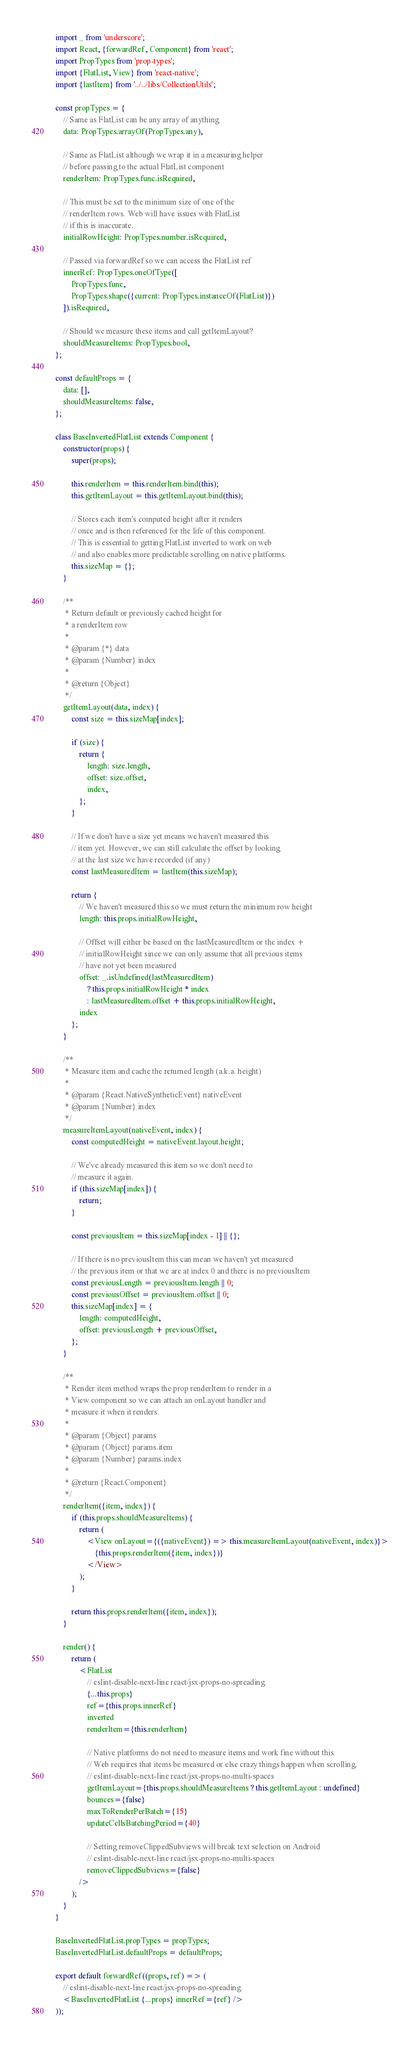Convert code to text. <code><loc_0><loc_0><loc_500><loc_500><_JavaScript_>import _ from 'underscore';
import React, {forwardRef, Component} from 'react';
import PropTypes from 'prop-types';
import {FlatList, View} from 'react-native';
import {lastItem} from '../../libs/CollectionUtils';

const propTypes = {
    // Same as FlatList can be any array of anything
    data: PropTypes.arrayOf(PropTypes.any),

    // Same as FlatList although we wrap it in a measuring helper
    // before passing to the actual FlatList component
    renderItem: PropTypes.func.isRequired,

    // This must be set to the minimum size of one of the
    // renderItem rows. Web will have issues with FlatList
    // if this is inaccurate.
    initialRowHeight: PropTypes.number.isRequired,

    // Passed via forwardRef so we can access the FlatList ref
    innerRef: PropTypes.oneOfType([
        PropTypes.func,
        PropTypes.shape({current: PropTypes.instanceOf(FlatList)})
    ]).isRequired,

    // Should we measure these items and call getItemLayout?
    shouldMeasureItems: PropTypes.bool,
};

const defaultProps = {
    data: [],
    shouldMeasureItems: false,
};

class BaseInvertedFlatList extends Component {
    constructor(props) {
        super(props);

        this.renderItem = this.renderItem.bind(this);
        this.getItemLayout = this.getItemLayout.bind(this);

        // Stores each item's computed height after it renders
        // once and is then referenced for the life of this component.
        // This is essential to getting FlatList inverted to work on web
        // and also enables more predictable scrolling on native platforms.
        this.sizeMap = {};
    }

    /**
     * Return default or previously cached height for
     * a renderItem row
     *
     * @param {*} data
     * @param {Number} index
     *
     * @return {Object}
     */
    getItemLayout(data, index) {
        const size = this.sizeMap[index];

        if (size) {
            return {
                length: size.length,
                offset: size.offset,
                index,
            };
        }

        // If we don't have a size yet means we haven't measured this
        // item yet. However, we can still calculate the offset by looking
        // at the last size we have recorded (if any)
        const lastMeasuredItem = lastItem(this.sizeMap);

        return {
            // We haven't measured this so we must return the minimum row height
            length: this.props.initialRowHeight,

            // Offset will either be based on the lastMeasuredItem or the index +
            // initialRowHeight since we can only assume that all previous items
            // have not yet been measured
            offset: _.isUndefined(lastMeasuredItem)
                ? this.props.initialRowHeight * index
                : lastMeasuredItem.offset + this.props.initialRowHeight,
            index
        };
    }

    /**
     * Measure item and cache the returned length (a.k.a. height)
     *
     * @param {React.NativeSyntheticEvent} nativeEvent
     * @param {Number} index
     */
    measureItemLayout(nativeEvent, index) {
        const computedHeight = nativeEvent.layout.height;

        // We've already measured this item so we don't need to
        // measure it again.
        if (this.sizeMap[index]) {
            return;
        }

        const previousItem = this.sizeMap[index - 1] || {};

        // If there is no previousItem this can mean we haven't yet measured
        // the previous item or that we are at index 0 and there is no previousItem
        const previousLength = previousItem.length || 0;
        const previousOffset = previousItem.offset || 0;
        this.sizeMap[index] = {
            length: computedHeight,
            offset: previousLength + previousOffset,
        };
    }

    /**
     * Render item method wraps the prop renderItem to render in a
     * View component so we can attach an onLayout handler and
     * measure it when it renders.
     *
     * @param {Object} params
     * @param {Object} params.item
     * @param {Number} params.index
     *
     * @return {React.Component}
     */
    renderItem({item, index}) {
        if (this.props.shouldMeasureItems) {
            return (
                <View onLayout={({nativeEvent}) => this.measureItemLayout(nativeEvent, index)}>
                    {this.props.renderItem({item, index})}
                </View>
            );
        }

        return this.props.renderItem({item, index});
    }

    render() {
        return (
            <FlatList
                // eslint-disable-next-line react/jsx-props-no-spreading
                {...this.props}
                ref={this.props.innerRef}
                inverted
                renderItem={this.renderItem}

                // Native platforms do not need to measure items and work fine without this.
                // Web requires that items be measured or else crazy things happen when scrolling.
                // eslint-disable-next-line react/jsx-props-no-multi-spaces
                getItemLayout={this.props.shouldMeasureItems ? this.getItemLayout : undefined}
                bounces={false}
                maxToRenderPerBatch={15}
                updateCellsBatchingPeriod={40}

                // Setting removeClippedSubviews will break text selection on Android
                // eslint-disable-next-line react/jsx-props-no-multi-spaces
                removeClippedSubviews={false}
            />
        );
    }
}

BaseInvertedFlatList.propTypes = propTypes;
BaseInvertedFlatList.defaultProps = defaultProps;

export default forwardRef((props, ref) => (
    // eslint-disable-next-line react/jsx-props-no-spreading
    <BaseInvertedFlatList {...props} innerRef={ref} />
));
</code> 